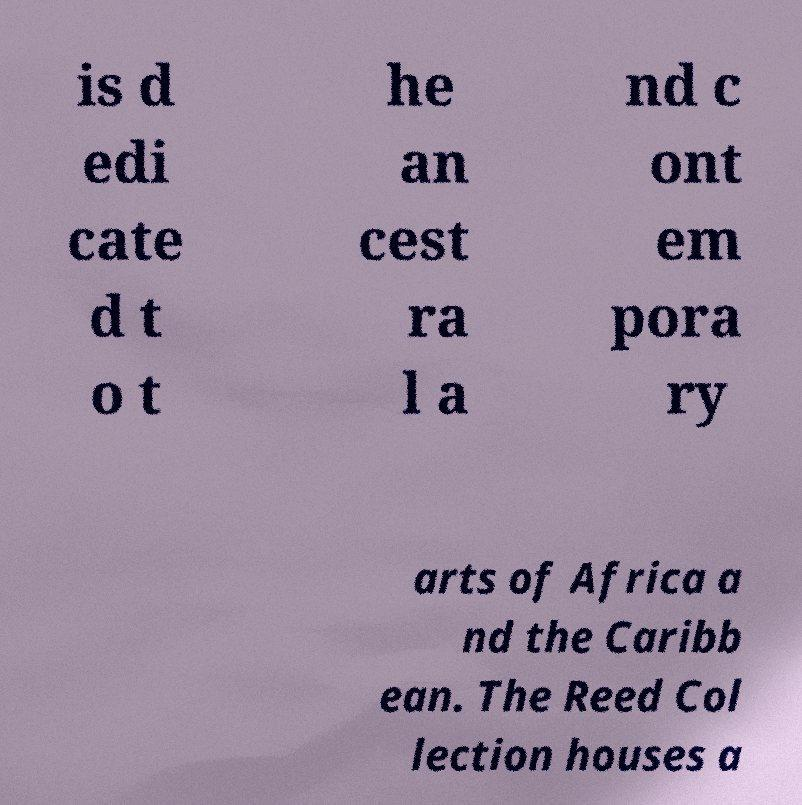Could you assist in decoding the text presented in this image and type it out clearly? is d edi cate d t o t he an cest ra l a nd c ont em pora ry arts of Africa a nd the Caribb ean. The Reed Col lection houses a 